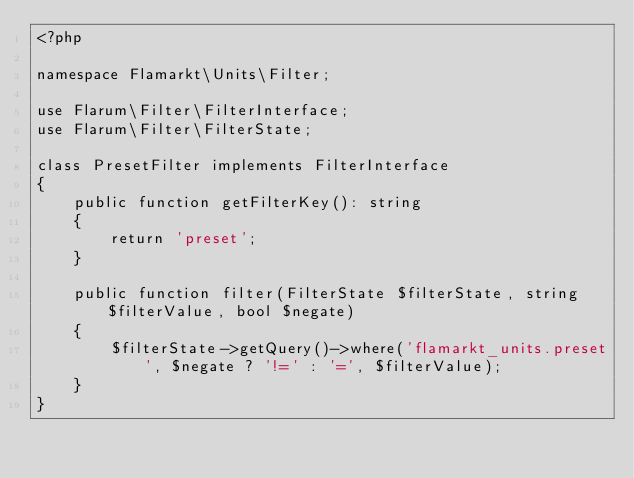Convert code to text. <code><loc_0><loc_0><loc_500><loc_500><_PHP_><?php

namespace Flamarkt\Units\Filter;

use Flarum\Filter\FilterInterface;
use Flarum\Filter\FilterState;

class PresetFilter implements FilterInterface
{
    public function getFilterKey(): string
    {
        return 'preset';
    }

    public function filter(FilterState $filterState, string $filterValue, bool $negate)
    {
        $filterState->getQuery()->where('flamarkt_units.preset', $negate ? '!=' : '=', $filterValue);
    }
}
</code> 